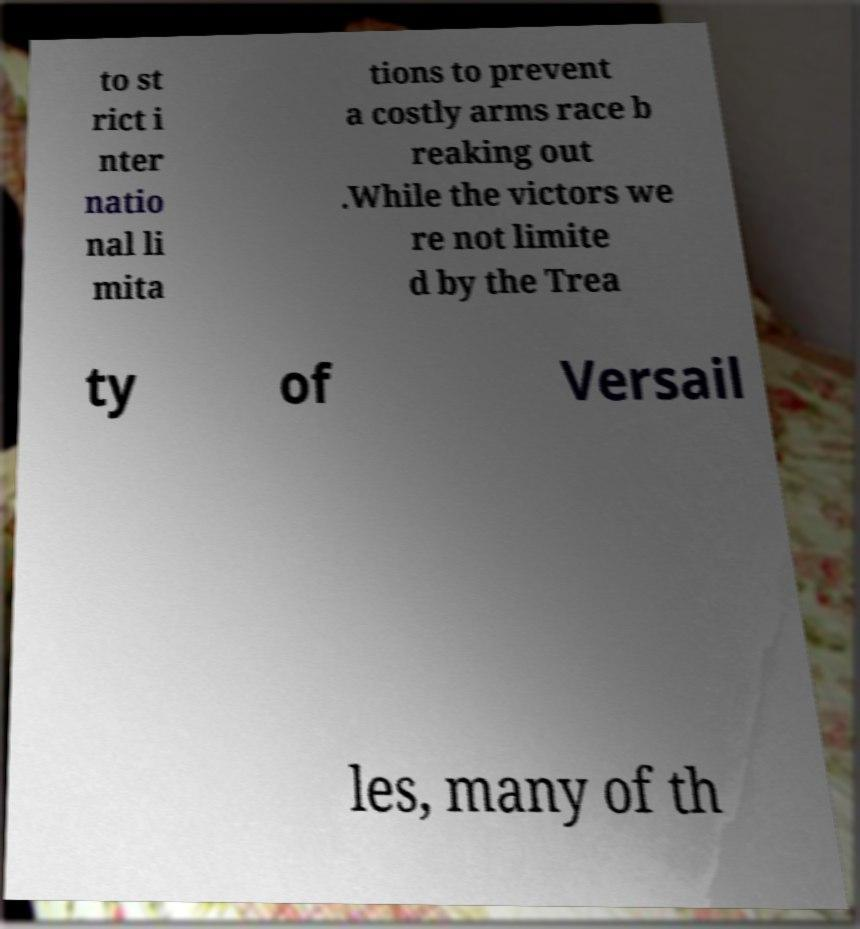Please identify and transcribe the text found in this image. to st rict i nter natio nal li mita tions to prevent a costly arms race b reaking out .While the victors we re not limite d by the Trea ty of Versail les, many of th 